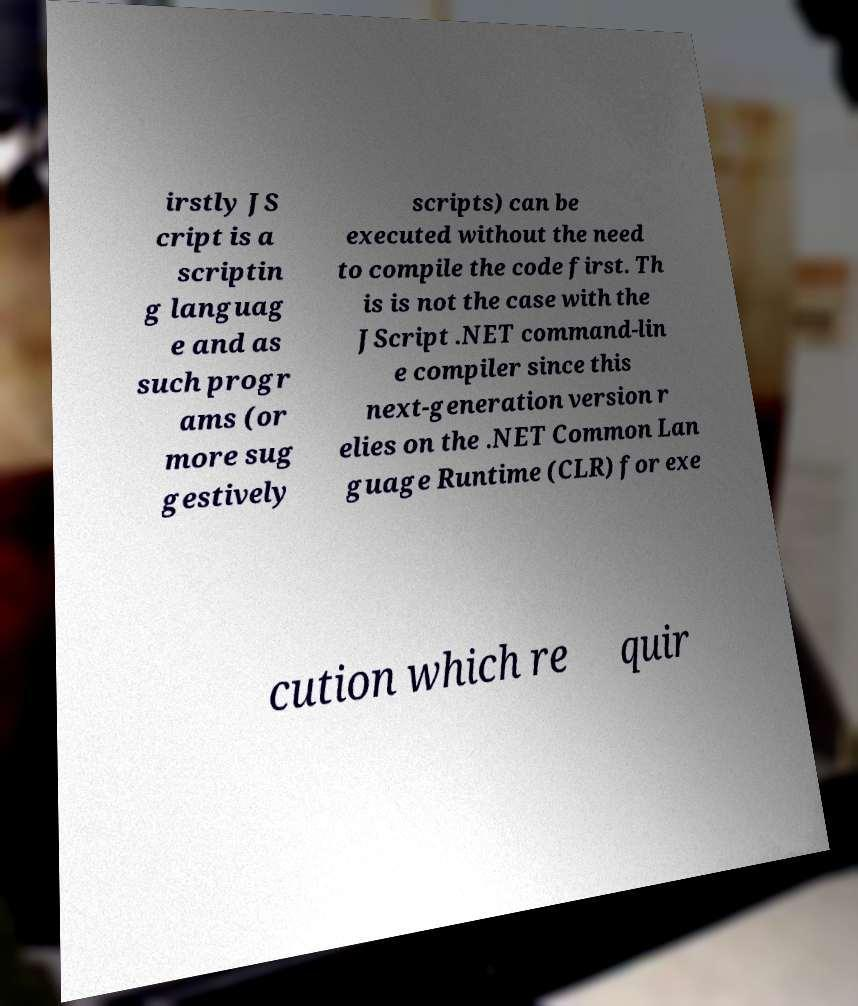Please identify and transcribe the text found in this image. irstly JS cript is a scriptin g languag e and as such progr ams (or more sug gestively scripts) can be executed without the need to compile the code first. Th is is not the case with the JScript .NET command-lin e compiler since this next-generation version r elies on the .NET Common Lan guage Runtime (CLR) for exe cution which re quir 